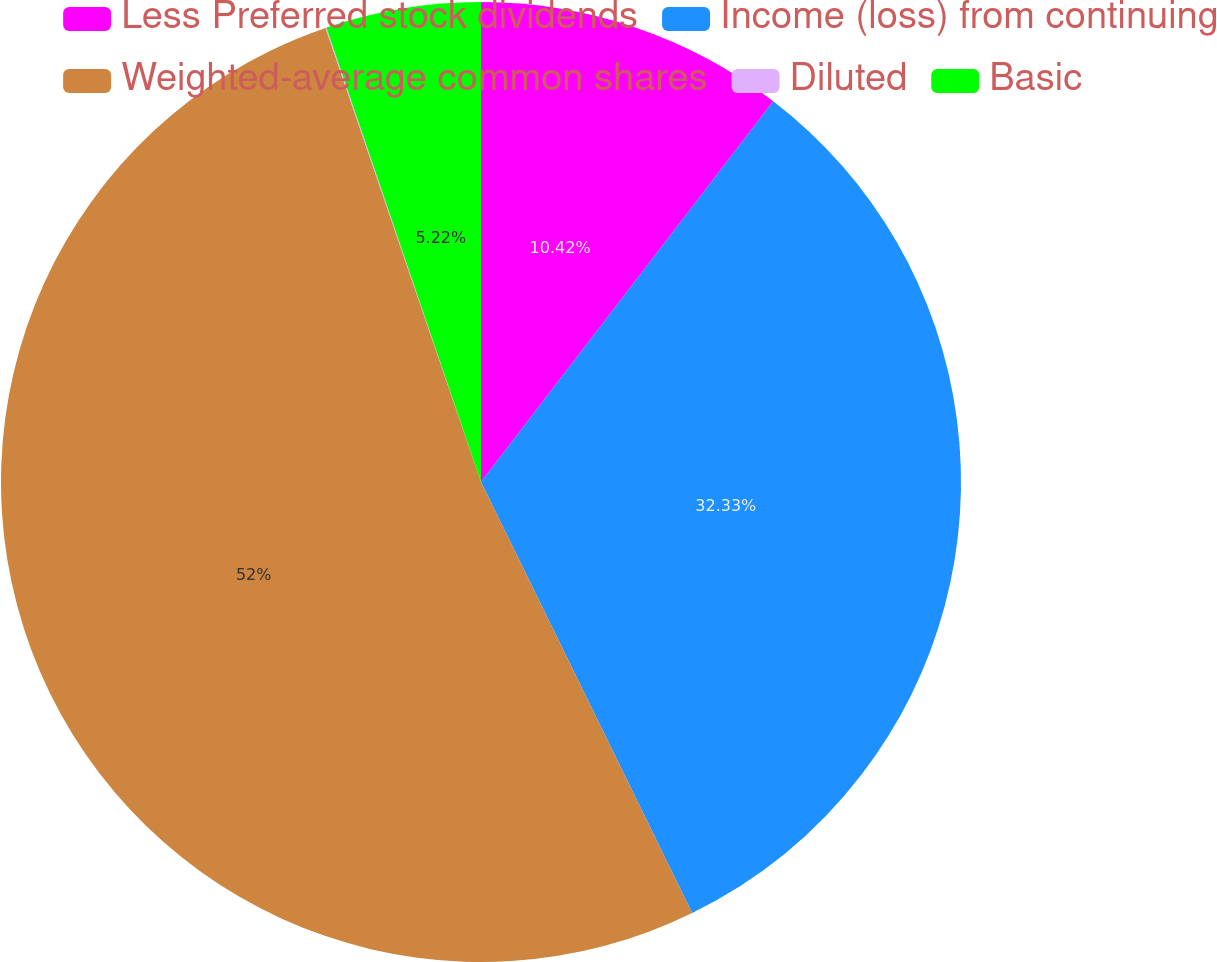<chart> <loc_0><loc_0><loc_500><loc_500><pie_chart><fcel>Less Preferred stock dividends<fcel>Income (loss) from continuing<fcel>Weighted-average common shares<fcel>Diluted<fcel>Basic<nl><fcel>10.42%<fcel>32.33%<fcel>52.0%<fcel>0.03%<fcel>5.22%<nl></chart> 